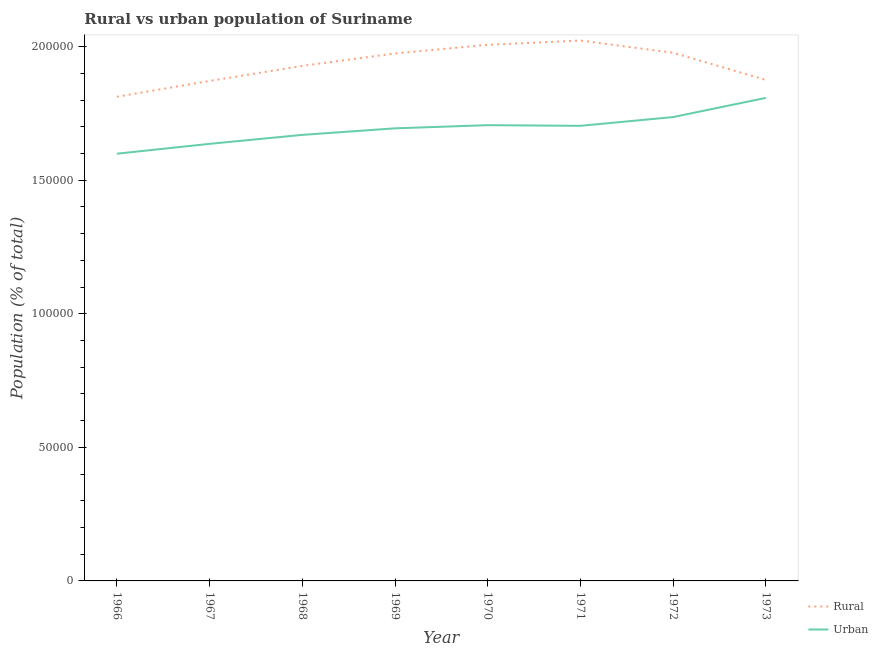Is the number of lines equal to the number of legend labels?
Make the answer very short. Yes. What is the urban population density in 1969?
Provide a succinct answer. 1.69e+05. Across all years, what is the maximum urban population density?
Provide a short and direct response. 1.81e+05. Across all years, what is the minimum rural population density?
Offer a terse response. 1.81e+05. In which year was the urban population density maximum?
Your response must be concise. 1973. In which year was the urban population density minimum?
Keep it short and to the point. 1966. What is the total rural population density in the graph?
Give a very brief answer. 1.55e+06. What is the difference between the urban population density in 1967 and that in 1969?
Your answer should be compact. -5803. What is the difference between the rural population density in 1966 and the urban population density in 1968?
Keep it short and to the point. 1.43e+04. What is the average urban population density per year?
Make the answer very short. 1.69e+05. In the year 1968, what is the difference between the urban population density and rural population density?
Give a very brief answer. -2.58e+04. In how many years, is the urban population density greater than 150000 %?
Provide a succinct answer. 8. What is the ratio of the rural population density in 1971 to that in 1973?
Offer a terse response. 1.08. Is the rural population density in 1968 less than that in 1972?
Make the answer very short. Yes. What is the difference between the highest and the second highest urban population density?
Offer a very short reply. 7180. What is the difference between the highest and the lowest urban population density?
Provide a succinct answer. 2.09e+04. Does the urban population density monotonically increase over the years?
Offer a very short reply. No. Is the urban population density strictly greater than the rural population density over the years?
Give a very brief answer. No. How many lines are there?
Ensure brevity in your answer.  2. What is the difference between two consecutive major ticks on the Y-axis?
Ensure brevity in your answer.  5.00e+04. Are the values on the major ticks of Y-axis written in scientific E-notation?
Your answer should be compact. No. What is the title of the graph?
Offer a very short reply. Rural vs urban population of Suriname. What is the label or title of the Y-axis?
Your answer should be very brief. Population (% of total). What is the Population (% of total) in Rural in 1966?
Provide a succinct answer. 1.81e+05. What is the Population (% of total) in Urban in 1966?
Your response must be concise. 1.60e+05. What is the Population (% of total) of Rural in 1967?
Offer a very short reply. 1.87e+05. What is the Population (% of total) of Urban in 1967?
Your response must be concise. 1.64e+05. What is the Population (% of total) in Rural in 1968?
Give a very brief answer. 1.93e+05. What is the Population (% of total) in Urban in 1968?
Offer a terse response. 1.67e+05. What is the Population (% of total) in Rural in 1969?
Your answer should be compact. 1.97e+05. What is the Population (% of total) in Urban in 1969?
Provide a succinct answer. 1.69e+05. What is the Population (% of total) in Rural in 1970?
Provide a succinct answer. 2.01e+05. What is the Population (% of total) in Urban in 1970?
Offer a very short reply. 1.71e+05. What is the Population (% of total) in Rural in 1971?
Give a very brief answer. 2.02e+05. What is the Population (% of total) of Urban in 1971?
Provide a short and direct response. 1.70e+05. What is the Population (% of total) of Rural in 1972?
Offer a terse response. 1.98e+05. What is the Population (% of total) of Urban in 1972?
Offer a very short reply. 1.74e+05. What is the Population (% of total) of Rural in 1973?
Offer a terse response. 1.88e+05. What is the Population (% of total) of Urban in 1973?
Your answer should be compact. 1.81e+05. Across all years, what is the maximum Population (% of total) of Rural?
Provide a short and direct response. 2.02e+05. Across all years, what is the maximum Population (% of total) in Urban?
Offer a very short reply. 1.81e+05. Across all years, what is the minimum Population (% of total) in Rural?
Your answer should be very brief. 1.81e+05. Across all years, what is the minimum Population (% of total) in Urban?
Make the answer very short. 1.60e+05. What is the total Population (% of total) in Rural in the graph?
Your answer should be compact. 1.55e+06. What is the total Population (% of total) in Urban in the graph?
Give a very brief answer. 1.36e+06. What is the difference between the Population (% of total) in Rural in 1966 and that in 1967?
Provide a succinct answer. -5927. What is the difference between the Population (% of total) in Urban in 1966 and that in 1967?
Your answer should be very brief. -3691. What is the difference between the Population (% of total) of Rural in 1966 and that in 1968?
Ensure brevity in your answer.  -1.16e+04. What is the difference between the Population (% of total) of Urban in 1966 and that in 1968?
Give a very brief answer. -7045. What is the difference between the Population (% of total) in Rural in 1966 and that in 1969?
Your answer should be compact. -1.62e+04. What is the difference between the Population (% of total) of Urban in 1966 and that in 1969?
Offer a terse response. -9494. What is the difference between the Population (% of total) in Rural in 1966 and that in 1970?
Offer a very short reply. -1.95e+04. What is the difference between the Population (% of total) in Urban in 1966 and that in 1970?
Provide a succinct answer. -1.07e+04. What is the difference between the Population (% of total) in Rural in 1966 and that in 1971?
Your response must be concise. -2.10e+04. What is the difference between the Population (% of total) in Urban in 1966 and that in 1971?
Give a very brief answer. -1.04e+04. What is the difference between the Population (% of total) of Rural in 1966 and that in 1972?
Make the answer very short. -1.65e+04. What is the difference between the Population (% of total) of Urban in 1966 and that in 1972?
Ensure brevity in your answer.  -1.37e+04. What is the difference between the Population (% of total) in Rural in 1966 and that in 1973?
Offer a terse response. -6312. What is the difference between the Population (% of total) in Urban in 1966 and that in 1973?
Your response must be concise. -2.09e+04. What is the difference between the Population (% of total) in Rural in 1967 and that in 1968?
Provide a short and direct response. -5626. What is the difference between the Population (% of total) of Urban in 1967 and that in 1968?
Your answer should be very brief. -3354. What is the difference between the Population (% of total) of Rural in 1967 and that in 1969?
Give a very brief answer. -1.03e+04. What is the difference between the Population (% of total) of Urban in 1967 and that in 1969?
Keep it short and to the point. -5803. What is the difference between the Population (% of total) of Rural in 1967 and that in 1970?
Your response must be concise. -1.35e+04. What is the difference between the Population (% of total) of Urban in 1967 and that in 1970?
Provide a succinct answer. -6984. What is the difference between the Population (% of total) in Rural in 1967 and that in 1971?
Provide a succinct answer. -1.51e+04. What is the difference between the Population (% of total) in Urban in 1967 and that in 1971?
Your response must be concise. -6741. What is the difference between the Population (% of total) in Rural in 1967 and that in 1972?
Give a very brief answer. -1.05e+04. What is the difference between the Population (% of total) of Urban in 1967 and that in 1972?
Provide a short and direct response. -1.00e+04. What is the difference between the Population (% of total) in Rural in 1967 and that in 1973?
Give a very brief answer. -385. What is the difference between the Population (% of total) of Urban in 1967 and that in 1973?
Ensure brevity in your answer.  -1.72e+04. What is the difference between the Population (% of total) of Rural in 1968 and that in 1969?
Ensure brevity in your answer.  -4661. What is the difference between the Population (% of total) of Urban in 1968 and that in 1969?
Your response must be concise. -2449. What is the difference between the Population (% of total) of Rural in 1968 and that in 1970?
Your answer should be compact. -7903. What is the difference between the Population (% of total) in Urban in 1968 and that in 1970?
Offer a terse response. -3630. What is the difference between the Population (% of total) of Rural in 1968 and that in 1971?
Your answer should be compact. -9497. What is the difference between the Population (% of total) in Urban in 1968 and that in 1971?
Your response must be concise. -3387. What is the difference between the Population (% of total) of Rural in 1968 and that in 1972?
Your answer should be compact. -4915. What is the difference between the Population (% of total) in Urban in 1968 and that in 1972?
Your answer should be compact. -6668. What is the difference between the Population (% of total) in Rural in 1968 and that in 1973?
Offer a very short reply. 5241. What is the difference between the Population (% of total) of Urban in 1968 and that in 1973?
Your answer should be compact. -1.38e+04. What is the difference between the Population (% of total) in Rural in 1969 and that in 1970?
Offer a very short reply. -3242. What is the difference between the Population (% of total) in Urban in 1969 and that in 1970?
Offer a very short reply. -1181. What is the difference between the Population (% of total) in Rural in 1969 and that in 1971?
Offer a terse response. -4836. What is the difference between the Population (% of total) of Urban in 1969 and that in 1971?
Give a very brief answer. -938. What is the difference between the Population (% of total) in Rural in 1969 and that in 1972?
Provide a short and direct response. -254. What is the difference between the Population (% of total) of Urban in 1969 and that in 1972?
Provide a succinct answer. -4219. What is the difference between the Population (% of total) in Rural in 1969 and that in 1973?
Your answer should be very brief. 9902. What is the difference between the Population (% of total) in Urban in 1969 and that in 1973?
Ensure brevity in your answer.  -1.14e+04. What is the difference between the Population (% of total) of Rural in 1970 and that in 1971?
Your response must be concise. -1594. What is the difference between the Population (% of total) of Urban in 1970 and that in 1971?
Your answer should be very brief. 243. What is the difference between the Population (% of total) of Rural in 1970 and that in 1972?
Ensure brevity in your answer.  2988. What is the difference between the Population (% of total) of Urban in 1970 and that in 1972?
Ensure brevity in your answer.  -3038. What is the difference between the Population (% of total) in Rural in 1970 and that in 1973?
Offer a terse response. 1.31e+04. What is the difference between the Population (% of total) in Urban in 1970 and that in 1973?
Make the answer very short. -1.02e+04. What is the difference between the Population (% of total) in Rural in 1971 and that in 1972?
Offer a very short reply. 4582. What is the difference between the Population (% of total) of Urban in 1971 and that in 1972?
Make the answer very short. -3281. What is the difference between the Population (% of total) of Rural in 1971 and that in 1973?
Offer a terse response. 1.47e+04. What is the difference between the Population (% of total) in Urban in 1971 and that in 1973?
Keep it short and to the point. -1.05e+04. What is the difference between the Population (% of total) in Rural in 1972 and that in 1973?
Provide a succinct answer. 1.02e+04. What is the difference between the Population (% of total) in Urban in 1972 and that in 1973?
Provide a short and direct response. -7180. What is the difference between the Population (% of total) of Rural in 1966 and the Population (% of total) of Urban in 1967?
Provide a succinct answer. 1.76e+04. What is the difference between the Population (% of total) of Rural in 1966 and the Population (% of total) of Urban in 1968?
Provide a short and direct response. 1.43e+04. What is the difference between the Population (% of total) of Rural in 1966 and the Population (% of total) of Urban in 1969?
Give a very brief answer. 1.18e+04. What is the difference between the Population (% of total) in Rural in 1966 and the Population (% of total) in Urban in 1970?
Provide a short and direct response. 1.06e+04. What is the difference between the Population (% of total) in Rural in 1966 and the Population (% of total) in Urban in 1971?
Keep it short and to the point. 1.09e+04. What is the difference between the Population (% of total) of Rural in 1966 and the Population (% of total) of Urban in 1972?
Your response must be concise. 7594. What is the difference between the Population (% of total) of Rural in 1966 and the Population (% of total) of Urban in 1973?
Offer a terse response. 414. What is the difference between the Population (% of total) of Rural in 1967 and the Population (% of total) of Urban in 1968?
Your answer should be very brief. 2.02e+04. What is the difference between the Population (% of total) in Rural in 1967 and the Population (% of total) in Urban in 1969?
Offer a terse response. 1.77e+04. What is the difference between the Population (% of total) of Rural in 1967 and the Population (% of total) of Urban in 1970?
Ensure brevity in your answer.  1.66e+04. What is the difference between the Population (% of total) of Rural in 1967 and the Population (% of total) of Urban in 1971?
Keep it short and to the point. 1.68e+04. What is the difference between the Population (% of total) of Rural in 1967 and the Population (% of total) of Urban in 1972?
Ensure brevity in your answer.  1.35e+04. What is the difference between the Population (% of total) in Rural in 1967 and the Population (% of total) in Urban in 1973?
Keep it short and to the point. 6341. What is the difference between the Population (% of total) of Rural in 1968 and the Population (% of total) of Urban in 1969?
Keep it short and to the point. 2.34e+04. What is the difference between the Population (% of total) of Rural in 1968 and the Population (% of total) of Urban in 1970?
Your answer should be very brief. 2.22e+04. What is the difference between the Population (% of total) of Rural in 1968 and the Population (% of total) of Urban in 1971?
Your answer should be very brief. 2.24e+04. What is the difference between the Population (% of total) in Rural in 1968 and the Population (% of total) in Urban in 1972?
Offer a very short reply. 1.91e+04. What is the difference between the Population (% of total) in Rural in 1968 and the Population (% of total) in Urban in 1973?
Provide a succinct answer. 1.20e+04. What is the difference between the Population (% of total) of Rural in 1969 and the Population (% of total) of Urban in 1970?
Give a very brief answer. 2.68e+04. What is the difference between the Population (% of total) of Rural in 1969 and the Population (% of total) of Urban in 1971?
Provide a short and direct response. 2.71e+04. What is the difference between the Population (% of total) of Rural in 1969 and the Population (% of total) of Urban in 1972?
Ensure brevity in your answer.  2.38e+04. What is the difference between the Population (% of total) of Rural in 1969 and the Population (% of total) of Urban in 1973?
Offer a very short reply. 1.66e+04. What is the difference between the Population (% of total) in Rural in 1970 and the Population (% of total) in Urban in 1971?
Offer a very short reply. 3.03e+04. What is the difference between the Population (% of total) of Rural in 1970 and the Population (% of total) of Urban in 1972?
Your answer should be compact. 2.70e+04. What is the difference between the Population (% of total) of Rural in 1970 and the Population (% of total) of Urban in 1973?
Your answer should be very brief. 1.99e+04. What is the difference between the Population (% of total) of Rural in 1971 and the Population (% of total) of Urban in 1972?
Offer a terse response. 2.86e+04. What is the difference between the Population (% of total) in Rural in 1971 and the Population (% of total) in Urban in 1973?
Provide a succinct answer. 2.15e+04. What is the difference between the Population (% of total) in Rural in 1972 and the Population (% of total) in Urban in 1973?
Make the answer very short. 1.69e+04. What is the average Population (% of total) of Rural per year?
Give a very brief answer. 1.93e+05. What is the average Population (% of total) in Urban per year?
Make the answer very short. 1.69e+05. In the year 1966, what is the difference between the Population (% of total) in Rural and Population (% of total) in Urban?
Ensure brevity in your answer.  2.13e+04. In the year 1967, what is the difference between the Population (% of total) of Rural and Population (% of total) of Urban?
Offer a very short reply. 2.35e+04. In the year 1968, what is the difference between the Population (% of total) of Rural and Population (% of total) of Urban?
Offer a very short reply. 2.58e+04. In the year 1969, what is the difference between the Population (% of total) in Rural and Population (% of total) in Urban?
Offer a very short reply. 2.80e+04. In the year 1970, what is the difference between the Population (% of total) of Rural and Population (% of total) of Urban?
Your response must be concise. 3.01e+04. In the year 1971, what is the difference between the Population (% of total) of Rural and Population (% of total) of Urban?
Your response must be concise. 3.19e+04. In the year 1972, what is the difference between the Population (% of total) of Rural and Population (% of total) of Urban?
Provide a succinct answer. 2.41e+04. In the year 1973, what is the difference between the Population (% of total) of Rural and Population (% of total) of Urban?
Keep it short and to the point. 6726. What is the ratio of the Population (% of total) in Rural in 1966 to that in 1967?
Offer a very short reply. 0.97. What is the ratio of the Population (% of total) in Urban in 1966 to that in 1967?
Your response must be concise. 0.98. What is the ratio of the Population (% of total) of Rural in 1966 to that in 1968?
Ensure brevity in your answer.  0.94. What is the ratio of the Population (% of total) in Urban in 1966 to that in 1968?
Your response must be concise. 0.96. What is the ratio of the Population (% of total) of Rural in 1966 to that in 1969?
Give a very brief answer. 0.92. What is the ratio of the Population (% of total) in Urban in 1966 to that in 1969?
Your answer should be compact. 0.94. What is the ratio of the Population (% of total) of Rural in 1966 to that in 1970?
Offer a very short reply. 0.9. What is the ratio of the Population (% of total) in Urban in 1966 to that in 1970?
Ensure brevity in your answer.  0.94. What is the ratio of the Population (% of total) in Rural in 1966 to that in 1971?
Keep it short and to the point. 0.9. What is the ratio of the Population (% of total) of Urban in 1966 to that in 1971?
Your answer should be very brief. 0.94. What is the ratio of the Population (% of total) of Urban in 1966 to that in 1972?
Your answer should be compact. 0.92. What is the ratio of the Population (% of total) in Rural in 1966 to that in 1973?
Your response must be concise. 0.97. What is the ratio of the Population (% of total) of Urban in 1966 to that in 1973?
Make the answer very short. 0.88. What is the ratio of the Population (% of total) in Rural in 1967 to that in 1968?
Provide a short and direct response. 0.97. What is the ratio of the Population (% of total) in Urban in 1967 to that in 1968?
Provide a short and direct response. 0.98. What is the ratio of the Population (% of total) in Rural in 1967 to that in 1969?
Provide a short and direct response. 0.95. What is the ratio of the Population (% of total) of Urban in 1967 to that in 1969?
Offer a terse response. 0.97. What is the ratio of the Population (% of total) in Rural in 1967 to that in 1970?
Offer a terse response. 0.93. What is the ratio of the Population (% of total) of Urban in 1967 to that in 1970?
Your answer should be very brief. 0.96. What is the ratio of the Population (% of total) of Rural in 1967 to that in 1971?
Offer a very short reply. 0.93. What is the ratio of the Population (% of total) in Urban in 1967 to that in 1971?
Give a very brief answer. 0.96. What is the ratio of the Population (% of total) of Rural in 1967 to that in 1972?
Your response must be concise. 0.95. What is the ratio of the Population (% of total) in Urban in 1967 to that in 1972?
Provide a short and direct response. 0.94. What is the ratio of the Population (% of total) of Urban in 1967 to that in 1973?
Your answer should be compact. 0.9. What is the ratio of the Population (% of total) in Rural in 1968 to that in 1969?
Keep it short and to the point. 0.98. What is the ratio of the Population (% of total) of Urban in 1968 to that in 1969?
Offer a very short reply. 0.99. What is the ratio of the Population (% of total) of Rural in 1968 to that in 1970?
Offer a very short reply. 0.96. What is the ratio of the Population (% of total) in Urban in 1968 to that in 1970?
Provide a short and direct response. 0.98. What is the ratio of the Population (% of total) in Rural in 1968 to that in 1971?
Provide a succinct answer. 0.95. What is the ratio of the Population (% of total) in Urban in 1968 to that in 1971?
Make the answer very short. 0.98. What is the ratio of the Population (% of total) in Rural in 1968 to that in 1972?
Give a very brief answer. 0.98. What is the ratio of the Population (% of total) in Urban in 1968 to that in 1972?
Make the answer very short. 0.96. What is the ratio of the Population (% of total) in Rural in 1968 to that in 1973?
Offer a very short reply. 1.03. What is the ratio of the Population (% of total) of Urban in 1968 to that in 1973?
Ensure brevity in your answer.  0.92. What is the ratio of the Population (% of total) of Rural in 1969 to that in 1970?
Provide a succinct answer. 0.98. What is the ratio of the Population (% of total) in Rural in 1969 to that in 1971?
Provide a short and direct response. 0.98. What is the ratio of the Population (% of total) in Urban in 1969 to that in 1972?
Ensure brevity in your answer.  0.98. What is the ratio of the Population (% of total) in Rural in 1969 to that in 1973?
Offer a terse response. 1.05. What is the ratio of the Population (% of total) of Urban in 1969 to that in 1973?
Make the answer very short. 0.94. What is the ratio of the Population (% of total) in Rural in 1970 to that in 1972?
Provide a short and direct response. 1.02. What is the ratio of the Population (% of total) in Urban in 1970 to that in 1972?
Your answer should be compact. 0.98. What is the ratio of the Population (% of total) of Rural in 1970 to that in 1973?
Provide a succinct answer. 1.07. What is the ratio of the Population (% of total) of Urban in 1970 to that in 1973?
Keep it short and to the point. 0.94. What is the ratio of the Population (% of total) in Rural in 1971 to that in 1972?
Make the answer very short. 1.02. What is the ratio of the Population (% of total) in Urban in 1971 to that in 1972?
Offer a very short reply. 0.98. What is the ratio of the Population (% of total) of Rural in 1971 to that in 1973?
Make the answer very short. 1.08. What is the ratio of the Population (% of total) of Urban in 1971 to that in 1973?
Provide a short and direct response. 0.94. What is the ratio of the Population (% of total) in Rural in 1972 to that in 1973?
Your answer should be very brief. 1.05. What is the ratio of the Population (% of total) in Urban in 1972 to that in 1973?
Offer a terse response. 0.96. What is the difference between the highest and the second highest Population (% of total) of Rural?
Provide a short and direct response. 1594. What is the difference between the highest and the second highest Population (% of total) in Urban?
Ensure brevity in your answer.  7180. What is the difference between the highest and the lowest Population (% of total) of Rural?
Your answer should be very brief. 2.10e+04. What is the difference between the highest and the lowest Population (% of total) in Urban?
Give a very brief answer. 2.09e+04. 